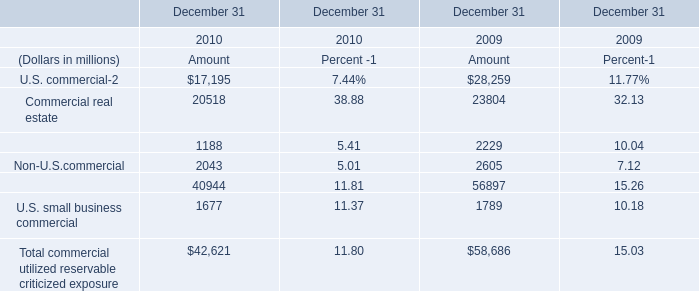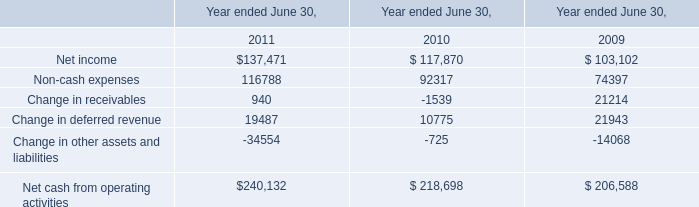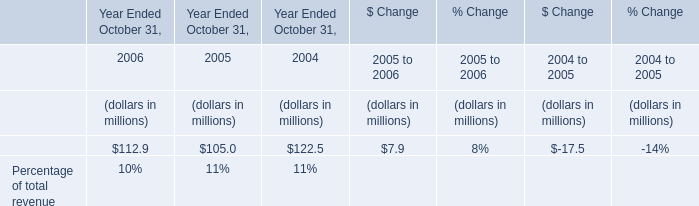what's the total amount of U.S. commercial of December 31 2009 Amount, Net income of Year ended June 30, 2011, and total of December 31 2010 Amount ? 
Computations: ((28259.0 + 137471.0) + 40944.0)
Answer: 206674.0. 